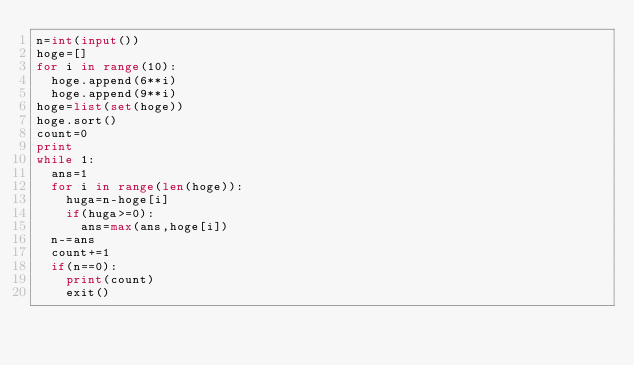Convert code to text. <code><loc_0><loc_0><loc_500><loc_500><_Python_>n=int(input())
hoge=[]
for i in range(10):
  hoge.append(6**i)
  hoge.append(9**i)
hoge=list(set(hoge))
hoge.sort()
count=0
print
while 1:
  ans=1
  for i in range(len(hoge)):
    huga=n-hoge[i]
    if(huga>=0):
      ans=max(ans,hoge[i])
  n-=ans
  count+=1
  if(n==0):
    print(count)
    exit()</code> 